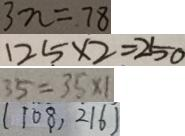<formula> <loc_0><loc_0><loc_500><loc_500>3 n = 7 8 
 1 2 5 \times 2 = 2 5 0 
 3 5 = 3 5 \times 1 
 ( 1 0 8 , 2 1 \dot { 6 } )</formula> 